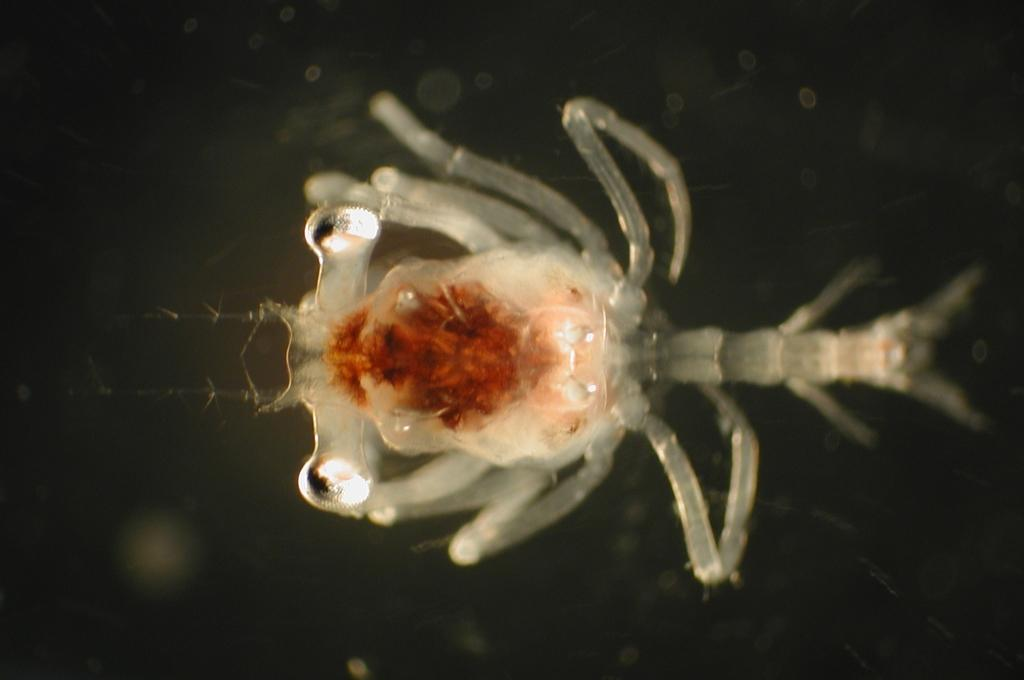What type of organism is present in the image? The image contains an organism with a transparent white color. Can you describe any other colors present in the image? Yes, there is a red color element in the image. What month is it in the image? The image does not depict a specific month or time of year, so it is not possible to determine the month from the image. 